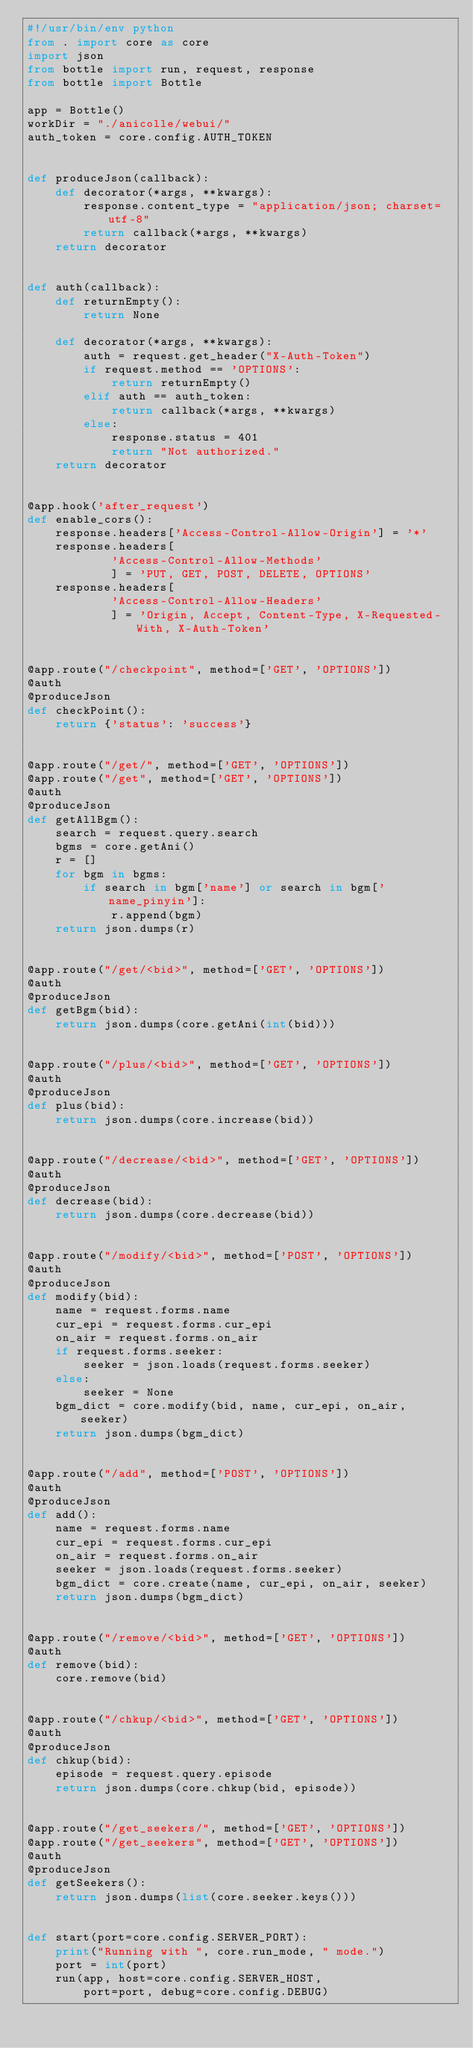Convert code to text. <code><loc_0><loc_0><loc_500><loc_500><_Python_>#!/usr/bin/env python
from . import core as core
import json
from bottle import run, request, response
from bottle import Bottle

app = Bottle()
workDir = "./anicolle/webui/"
auth_token = core.config.AUTH_TOKEN


def produceJson(callback):
    def decorator(*args, **kwargs):
        response.content_type = "application/json; charset=utf-8"
        return callback(*args, **kwargs)
    return decorator


def auth(callback):
    def returnEmpty():
        return None

    def decorator(*args, **kwargs):
        auth = request.get_header("X-Auth-Token")
        if request.method == 'OPTIONS':
            return returnEmpty()
        elif auth == auth_token:
            return callback(*args, **kwargs)
        else:
            response.status = 401
            return "Not authorized."
    return decorator


@app.hook('after_request')
def enable_cors():
    response.headers['Access-Control-Allow-Origin'] = '*'
    response.headers[
            'Access-Control-Allow-Methods'
            ] = 'PUT, GET, POST, DELETE, OPTIONS'
    response.headers[
            'Access-Control-Allow-Headers'
            ] = 'Origin, Accept, Content-Type, X-Requested-With, X-Auth-Token'


@app.route("/checkpoint", method=['GET', 'OPTIONS'])
@auth
@produceJson
def checkPoint():
    return {'status': 'success'}


@app.route("/get/", method=['GET', 'OPTIONS'])
@app.route("/get", method=['GET', 'OPTIONS'])
@auth
@produceJson
def getAllBgm():
    search = request.query.search
    bgms = core.getAni()
    r = []
    for bgm in bgms:
        if search in bgm['name'] or search in bgm['name_pinyin']:
            r.append(bgm)
    return json.dumps(r)


@app.route("/get/<bid>", method=['GET', 'OPTIONS'])
@auth
@produceJson
def getBgm(bid):
    return json.dumps(core.getAni(int(bid)))


@app.route("/plus/<bid>", method=['GET', 'OPTIONS'])
@auth
@produceJson
def plus(bid):
    return json.dumps(core.increase(bid))


@app.route("/decrease/<bid>", method=['GET', 'OPTIONS'])
@auth
@produceJson
def decrease(bid):
    return json.dumps(core.decrease(bid))


@app.route("/modify/<bid>", method=['POST', 'OPTIONS'])
@auth
@produceJson
def modify(bid):
    name = request.forms.name
    cur_epi = request.forms.cur_epi
    on_air = request.forms.on_air
    if request.forms.seeker:
        seeker = json.loads(request.forms.seeker)
    else:
        seeker = None
    bgm_dict = core.modify(bid, name, cur_epi, on_air, seeker)
    return json.dumps(bgm_dict)


@app.route("/add", method=['POST', 'OPTIONS'])
@auth
@produceJson
def add():
    name = request.forms.name
    cur_epi = request.forms.cur_epi
    on_air = request.forms.on_air
    seeker = json.loads(request.forms.seeker)
    bgm_dict = core.create(name, cur_epi, on_air, seeker)
    return json.dumps(bgm_dict)


@app.route("/remove/<bid>", method=['GET', 'OPTIONS'])
@auth
def remove(bid):
    core.remove(bid)


@app.route("/chkup/<bid>", method=['GET', 'OPTIONS'])
@auth
@produceJson
def chkup(bid):
    episode = request.query.episode
    return json.dumps(core.chkup(bid, episode))


@app.route("/get_seekers/", method=['GET', 'OPTIONS'])
@app.route("/get_seekers", method=['GET', 'OPTIONS'])
@auth
@produceJson
def getSeekers():
    return json.dumps(list(core.seeker.keys()))


def start(port=core.config.SERVER_PORT):
    print("Running with ", core.run_mode, " mode.")
    port = int(port)
    run(app, host=core.config.SERVER_HOST,
        port=port, debug=core.config.DEBUG)
</code> 